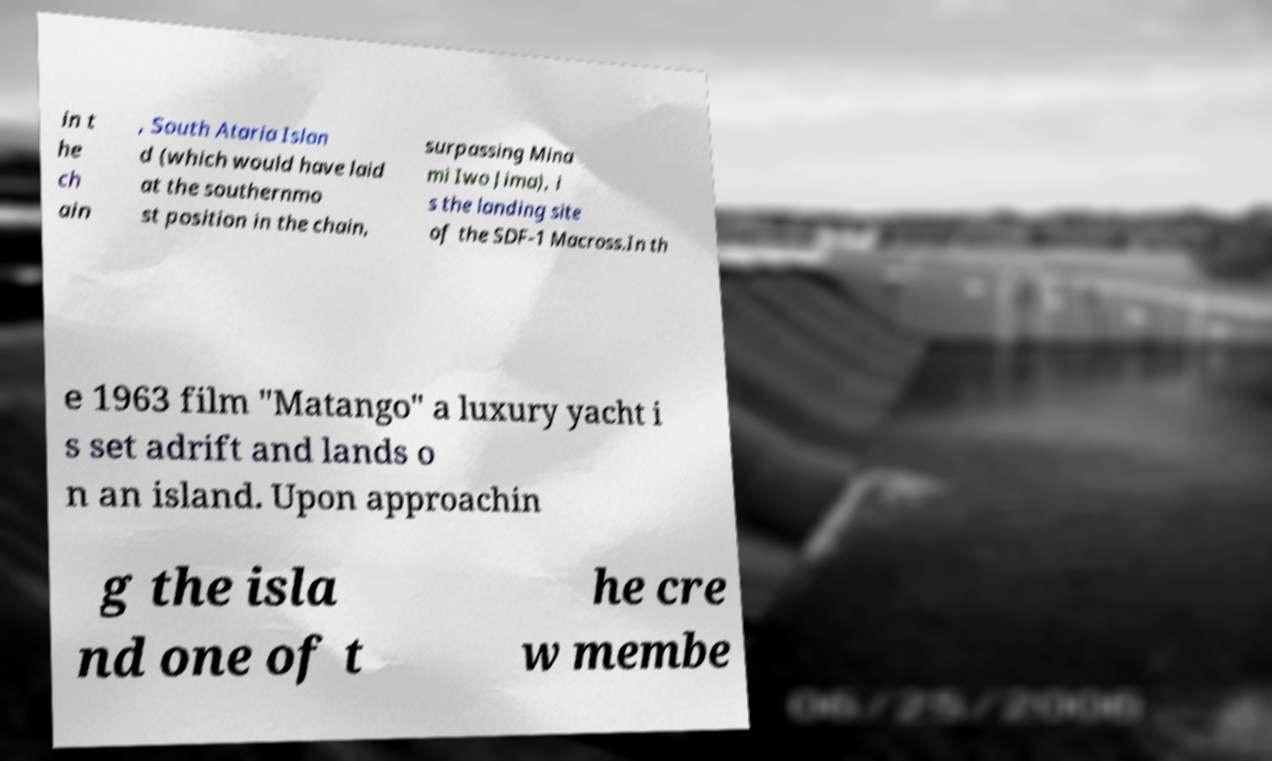For documentation purposes, I need the text within this image transcribed. Could you provide that? in t he ch ain , South Ataria Islan d (which would have laid at the southernmo st position in the chain, surpassing Mina mi Iwo Jima), i s the landing site of the SDF-1 Macross.In th e 1963 film "Matango" a luxury yacht i s set adrift and lands o n an island. Upon approachin g the isla nd one of t he cre w membe 